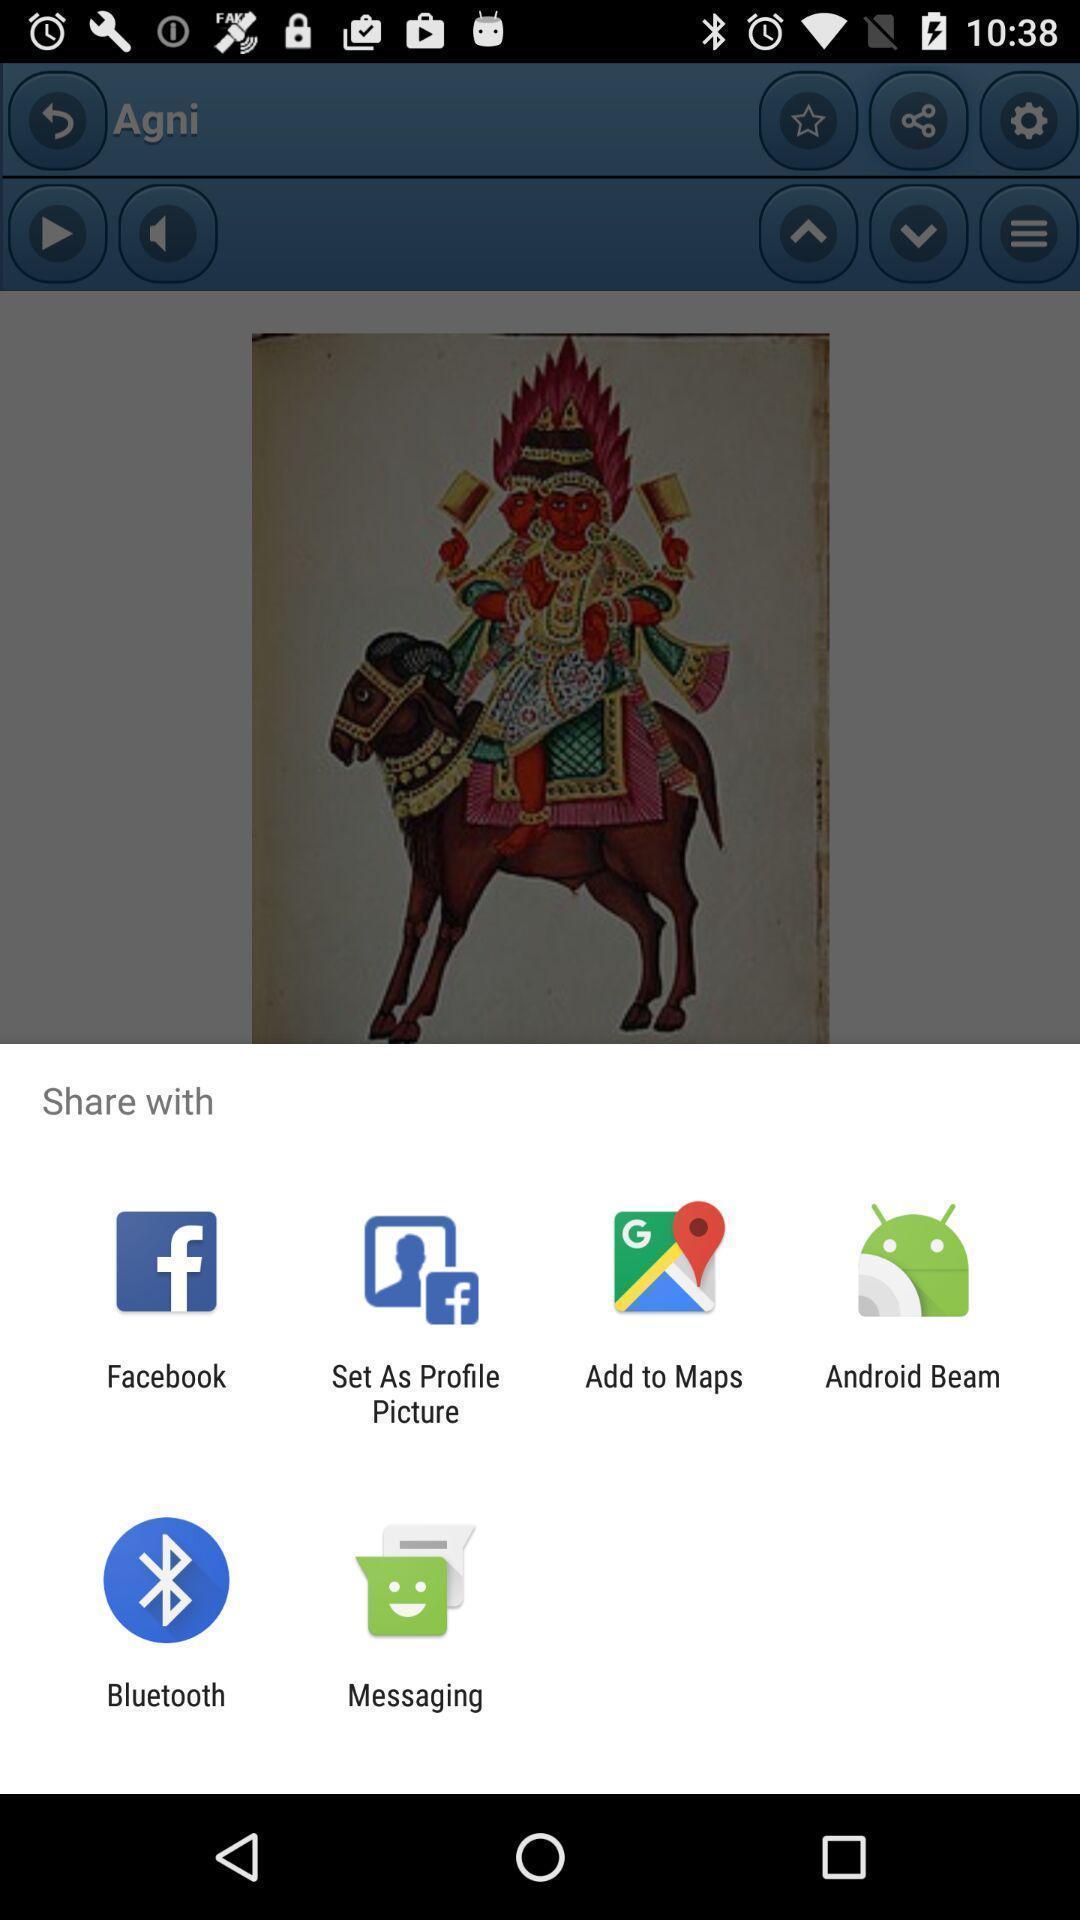Summarize the information in this screenshot. Pop-up widget is displaying different data sharing apps. 